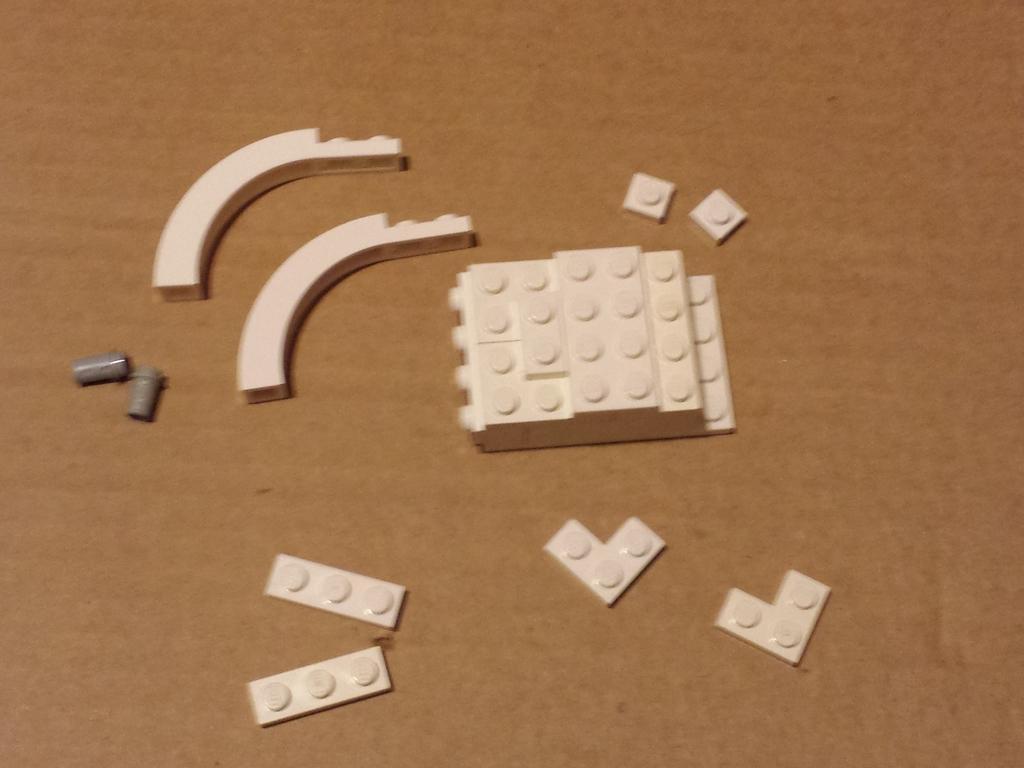Could you give a brief overview of what you see in this image? In this image we can see legos placed on the table. 